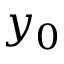Convert formula to latex. <formula><loc_0><loc_0><loc_500><loc_500>y _ { 0 }</formula> 